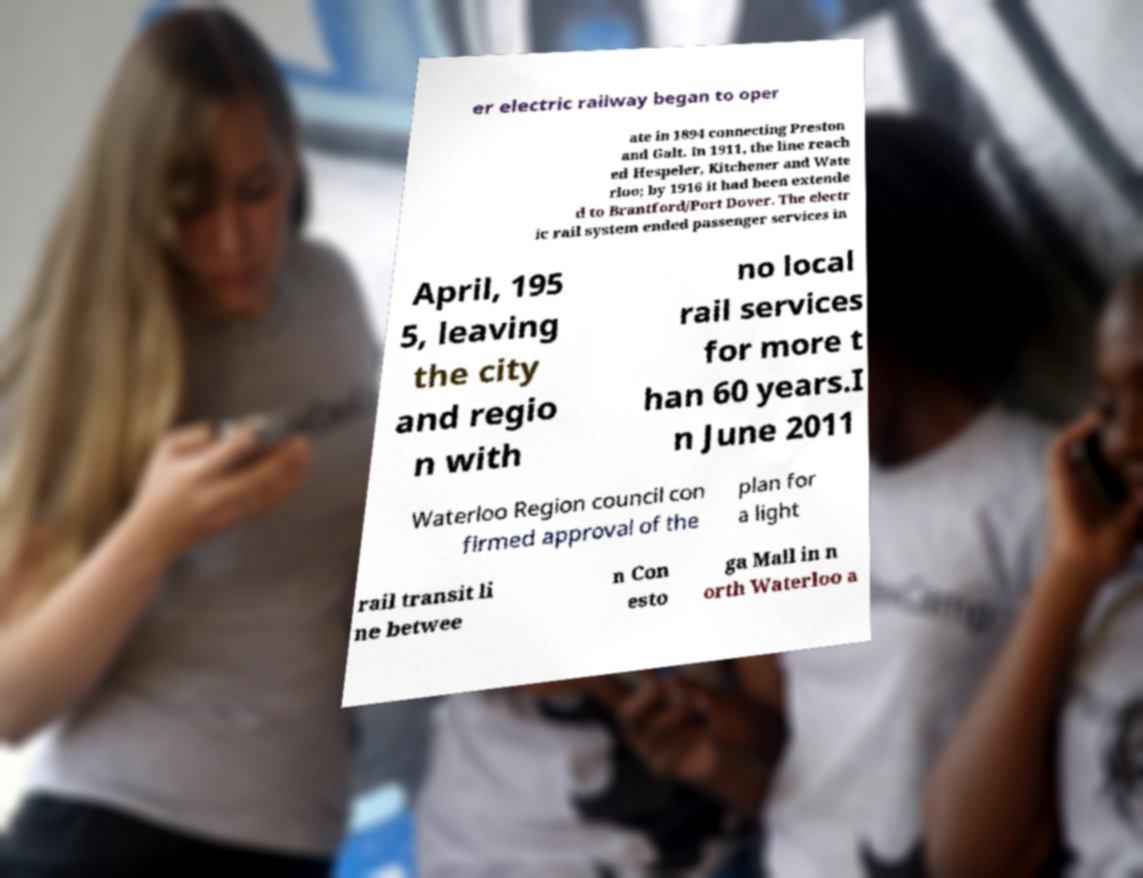There's text embedded in this image that I need extracted. Can you transcribe it verbatim? er electric railway began to oper ate in 1894 connecting Preston and Galt. In 1911, the line reach ed Hespeler, Kitchener and Wate rloo; by 1916 it had been extende d to Brantford/Port Dover. The electr ic rail system ended passenger services in April, 195 5, leaving the city and regio n with no local rail services for more t han 60 years.I n June 2011 Waterloo Region council con firmed approval of the plan for a light rail transit li ne betwee n Con esto ga Mall in n orth Waterloo a 